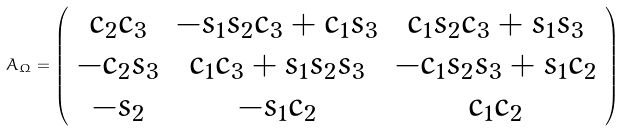<formula> <loc_0><loc_0><loc_500><loc_500>A _ { \Omega } = \left ( \begin{array} { c c c } c _ { 2 } c _ { 3 } & - s _ { 1 } s _ { 2 } c _ { 3 } + c _ { 1 } s _ { 3 } & c _ { 1 } s _ { 2 } c _ { 3 } + s _ { 1 } s _ { 3 } \\ - c _ { 2 } s _ { 3 } & c _ { 1 } c _ { 3 } + s _ { 1 } s _ { 2 } s _ { 3 } & - c _ { 1 } s _ { 2 } s _ { 3 } + s _ { 1 } c _ { 2 } \\ - s _ { 2 } & - s _ { 1 } c _ { 2 } & c _ { 1 } c _ { 2 } \end{array} \right ) \</formula> 